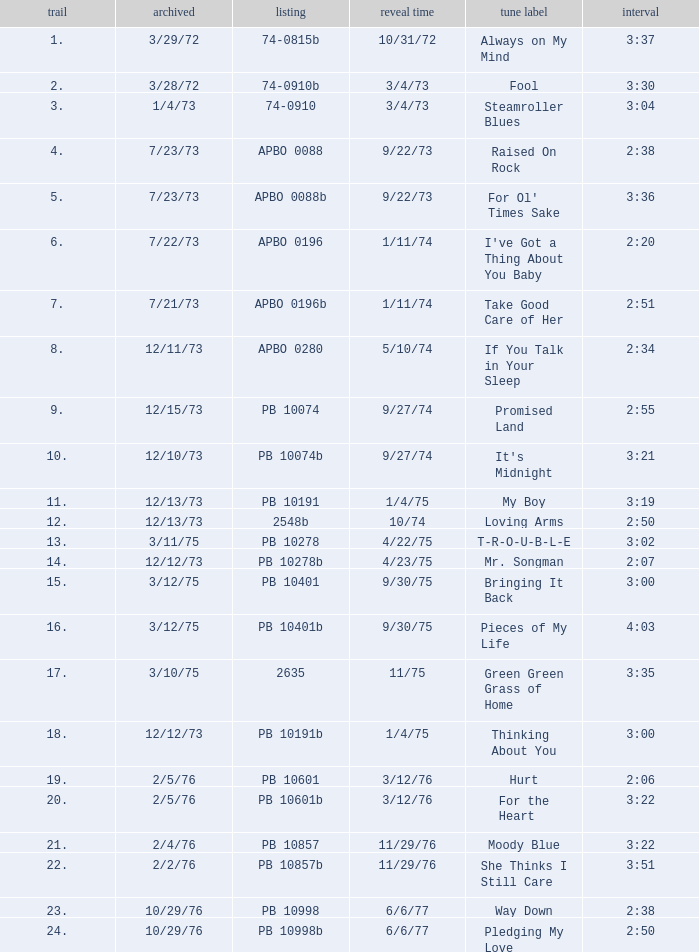Tell me the release date record on 10/29/76 and a time on 2:50 6/6/77. 